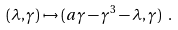<formula> <loc_0><loc_0><loc_500><loc_500>( \lambda , \gamma ) \mapsto ( a \gamma - \gamma ^ { 3 } - \lambda , \gamma ) \ .</formula> 